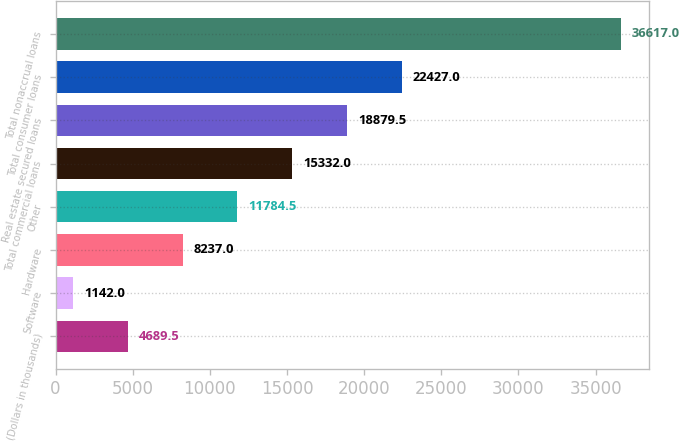Convert chart to OTSL. <chart><loc_0><loc_0><loc_500><loc_500><bar_chart><fcel>(Dollars in thousands)<fcel>Software<fcel>Hardware<fcel>Other<fcel>Total commercial loans<fcel>Real estate secured loans<fcel>Total consumer loans<fcel>Total nonaccrual loans<nl><fcel>4689.5<fcel>1142<fcel>8237<fcel>11784.5<fcel>15332<fcel>18879.5<fcel>22427<fcel>36617<nl></chart> 